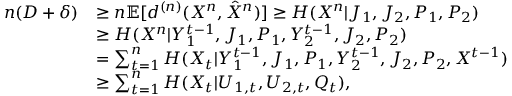<formula> <loc_0><loc_0><loc_500><loc_500>\begin{array} { r l } { n ( D + \delta ) } & { \geq { n } \mathbb { E } [ d ^ { ( n ) } ( X ^ { n } , \hat { X } ^ { n } ) ] \geq H ( X ^ { n } | J _ { 1 } , J _ { 2 } , P _ { 1 } , P _ { 2 } ) } \\ & { \geq H ( X ^ { n } | Y _ { 1 } ^ { t - 1 } , J _ { 1 } , { P _ { 1 } } , Y _ { 2 } ^ { t - 1 } , J _ { 2 } , P _ { 2 } ) } \\ & { = \sum _ { t = 1 } ^ { n } H ( X _ { t } | Y _ { 1 } ^ { t - 1 } , J _ { 1 } , { P _ { 1 } } , Y _ { 2 } ^ { t - 1 } , J _ { 2 } , P _ { 2 } , X ^ { t - 1 } ) } \\ & { \geq \sum _ { t = 1 } ^ { n } H ( X _ { t } | U _ { 1 , t } , U _ { 2 , t } , Q _ { t } ) , } \end{array}</formula> 